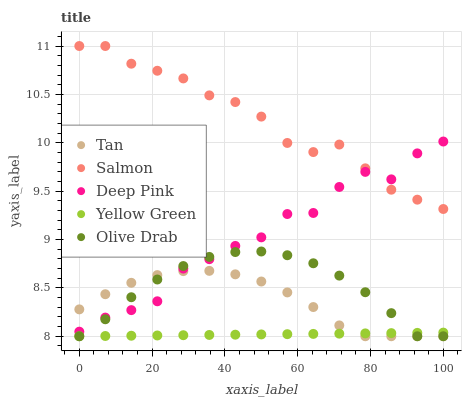Does Yellow Green have the minimum area under the curve?
Answer yes or no. Yes. Does Salmon have the maximum area under the curve?
Answer yes or no. Yes. Does Deep Pink have the minimum area under the curve?
Answer yes or no. No. Does Deep Pink have the maximum area under the curve?
Answer yes or no. No. Is Yellow Green the smoothest?
Answer yes or no. Yes. Is Deep Pink the roughest?
Answer yes or no. Yes. Is Salmon the smoothest?
Answer yes or no. No. Is Salmon the roughest?
Answer yes or no. No. Does Tan have the lowest value?
Answer yes or no. Yes. Does Deep Pink have the lowest value?
Answer yes or no. No. Does Salmon have the highest value?
Answer yes or no. Yes. Does Deep Pink have the highest value?
Answer yes or no. No. Is Tan less than Salmon?
Answer yes or no. Yes. Is Salmon greater than Yellow Green?
Answer yes or no. Yes. Does Yellow Green intersect Olive Drab?
Answer yes or no. Yes. Is Yellow Green less than Olive Drab?
Answer yes or no. No. Is Yellow Green greater than Olive Drab?
Answer yes or no. No. Does Tan intersect Salmon?
Answer yes or no. No. 